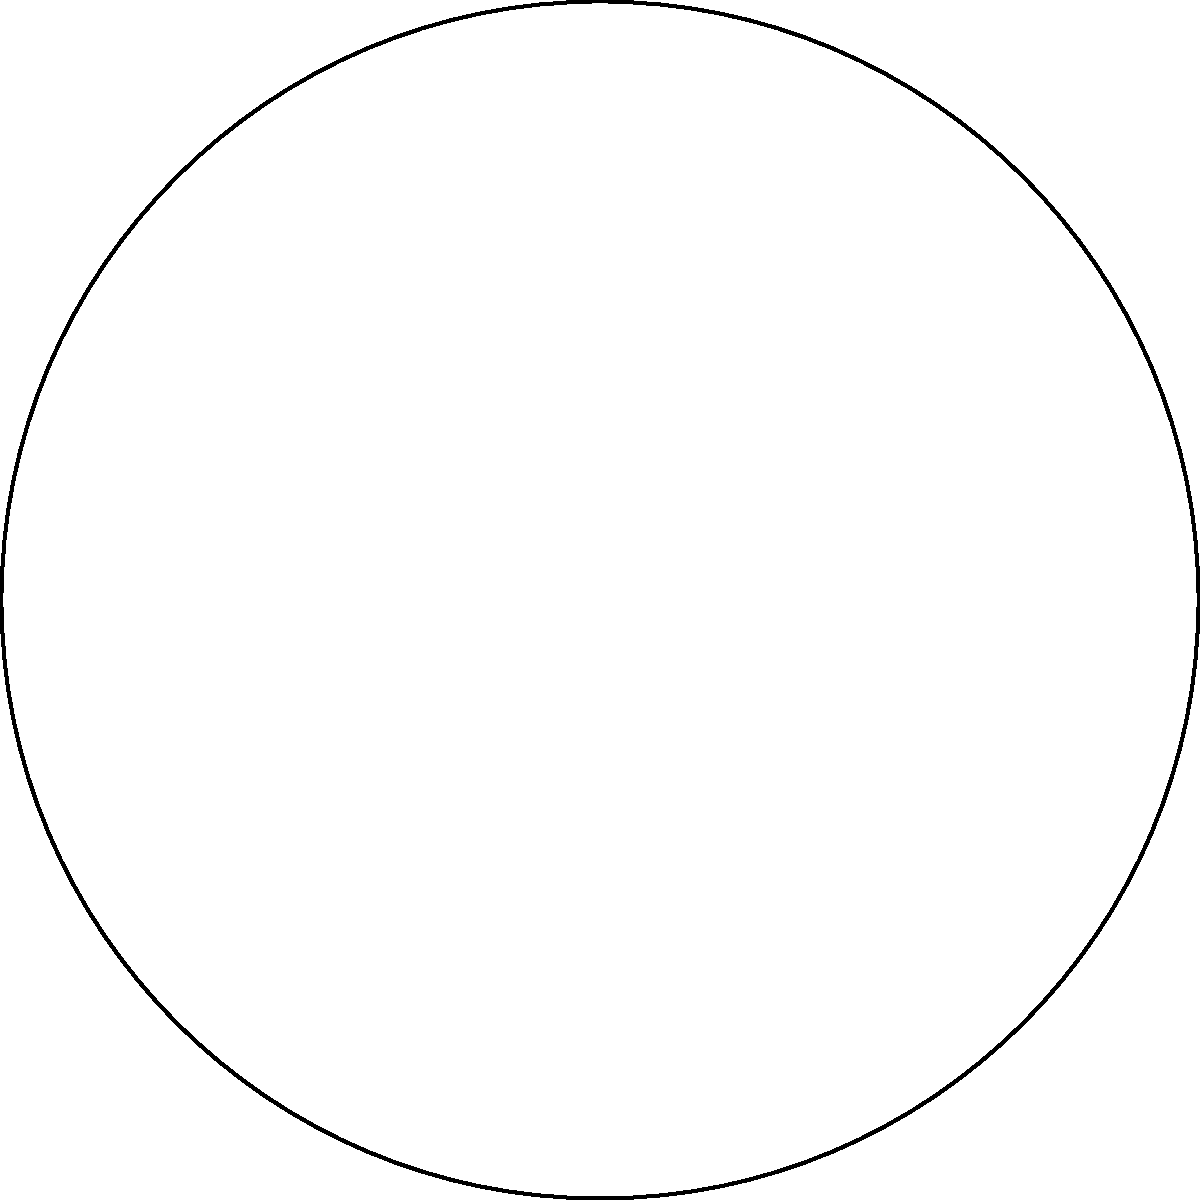Consider a triangle ABC on the surface of a sphere, as shown in the figure. If the interior angles of this spherical triangle are 70°, 80°, and 100°, what is the sum of these angles, and how does it compare to the sum of interior angles in a planar Euclidean triangle? To solve this problem, let's follow these steps:

1. Recall that in Euclidean geometry, the sum of interior angles of a triangle is always 180°.

2. In spherical geometry (a type of non-Euclidean geometry), the sum of interior angles of a triangle is always greater than 180°.

3. Calculate the sum of the given angles:
   $70° + 80° + 100° = 250°$

4. Compare this sum to 180°:
   $250° - 180° = 70°$

5. The difference between the sum of angles in this spherical triangle and a Euclidean triangle is 70°.

6. In spherical geometry, this difference is related to the area of the triangle on the sphere's surface. The excess angle (70° in this case) is directly proportional to the area of the spherical triangle.

7. This property is described by Girard's Theorem, which states that for a spherical triangle, the area $A$ is given by:
   $A = R^2(α + β + γ - π)$
   where $R$ is the radius of the sphere, and $α$, $β$, and $γ$ are the angles of the triangle in radians.

8. The excess angle (in radians) is precisely the term $(α + β + γ - π)$ in Girard's Theorem.
Answer: 250°; 70° greater than a Euclidean triangle 